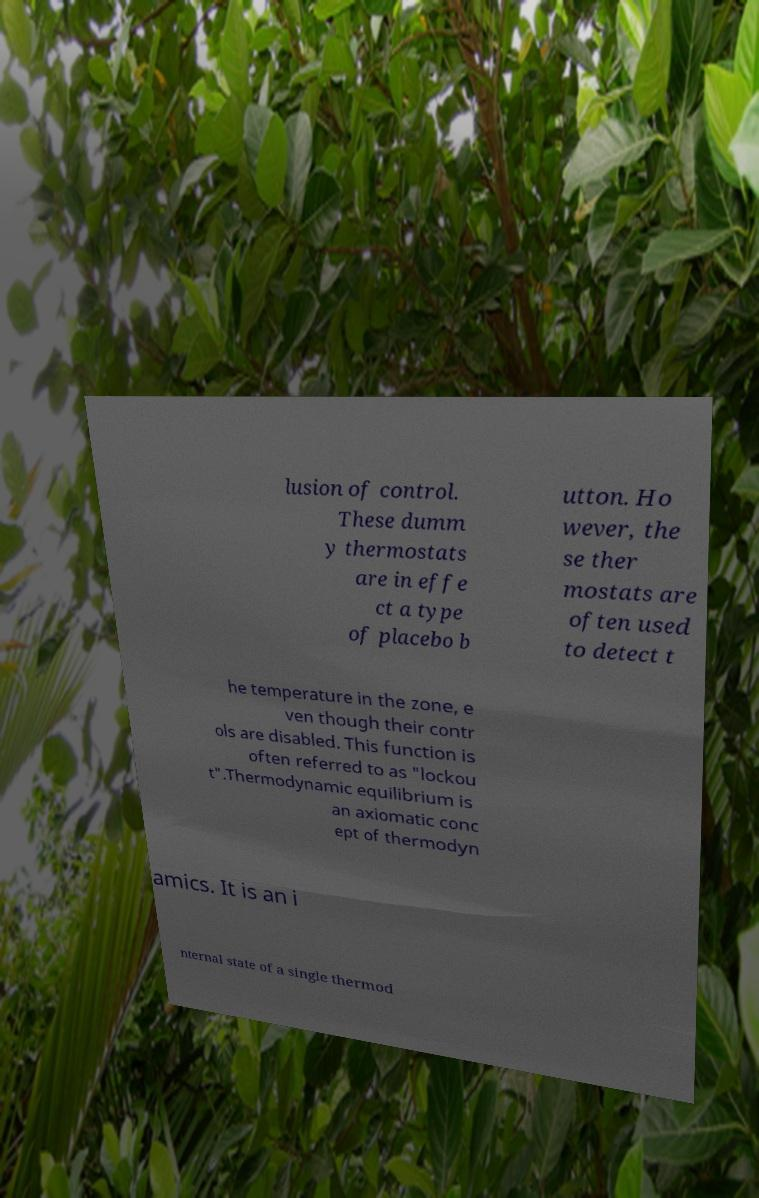There's text embedded in this image that I need extracted. Can you transcribe it verbatim? lusion of control. These dumm y thermostats are in effe ct a type of placebo b utton. Ho wever, the se ther mostats are often used to detect t he temperature in the zone, e ven though their contr ols are disabled. This function is often referred to as "lockou t".Thermodynamic equilibrium is an axiomatic conc ept of thermodyn amics. It is an i nternal state of a single thermod 